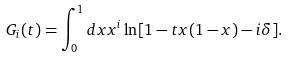<formula> <loc_0><loc_0><loc_500><loc_500>G _ { i } ( t ) = \int ^ { 1 } _ { 0 } d x x ^ { i } \ln [ 1 - t x ( 1 - x ) - i \delta ] .</formula> 